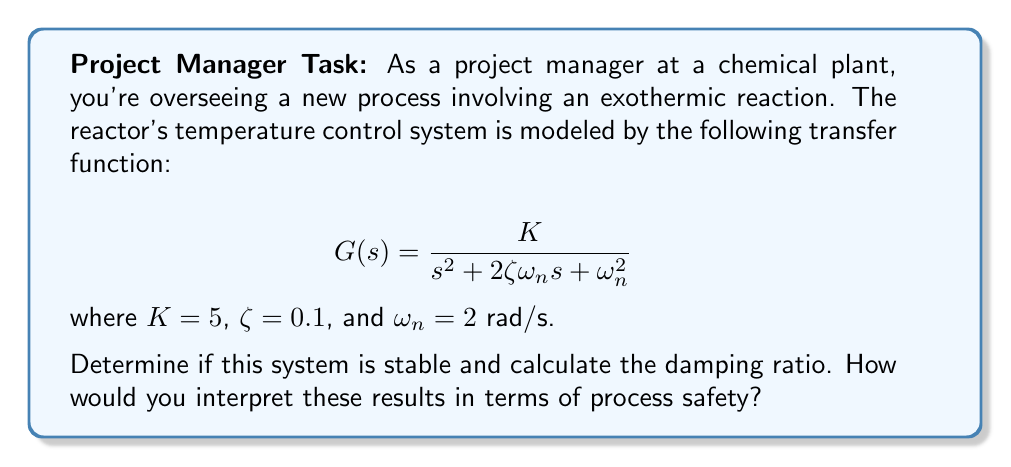Show me your answer to this math problem. To determine the stability of the system and calculate the damping ratio, we'll follow these steps:

1) The characteristic equation of the system is the denominator of the transfer function set to zero:

   $$s^2 + 2\zeta\omega_n s + \omega_n^2 = 0$$

2) For a second-order system to be stable, all coefficients must be positive and non-zero. In this case:
   - Coefficient of $s^2$: 1 > 0
   - Coefficient of $s$: $2\zeta\omega_n = 2(0.1)(2) = 0.4 > 0$
   - Constant term: $\omega_n^2 = 2^2 = 4 > 0$

   All coefficients are positive, so the system is stable.

3) The damping ratio $\zeta$ is given directly as 0.1.

4) Interpretation for process safety:
   - The system is stable, which is crucial for safe operation.
   - However, the damping ratio of 0.1 indicates an underdamped system (0 < $\zeta$ < 1).
   - An underdamped system will have oscillations before settling, which could lead to temperature fluctuations in the reactor.
   - Such fluctuations could potentially compromise safety if they exceed safe operating limits.

5) To visualize the system's response, we can plot the step response:

[asy]
import graph;
size(200,150);
real f(real t) {return 5*(1-exp(-0.2*t)*(cos(1.98*t)+0.1*sin(1.98*t)));}
draw(graph(f,0,20),red);
xaxis("Time (s)",Arrow);
yaxis("Response",Arrow);
label("Step Response",point(N),N);
[/asy]

This plot shows the oscillatory behavior of the system, which could represent temperature fluctuations in the reactor.
Answer: The system is stable but underdamped ($\zeta = 0.1$), potentially causing safety concerns due to temperature oscillations. 